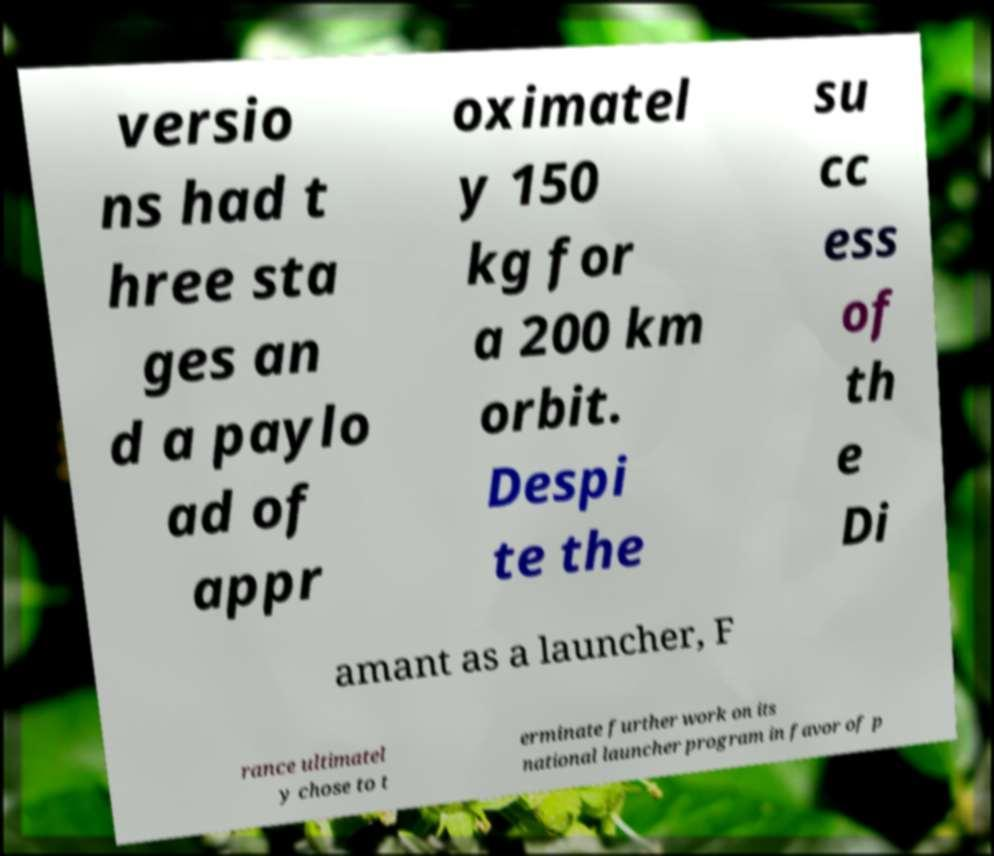Please identify and transcribe the text found in this image. versio ns had t hree sta ges an d a paylo ad of appr oximatel y 150 kg for a 200 km orbit. Despi te the su cc ess of th e Di amant as a launcher, F rance ultimatel y chose to t erminate further work on its national launcher program in favor of p 